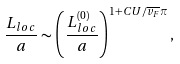Convert formula to latex. <formula><loc_0><loc_0><loc_500><loc_500>\frac { L _ { l o c } } { a } \sim \left ( \frac { L _ { l o c } ^ { ( 0 ) } } { a } \right ) ^ { 1 + C U / \overline { v _ { F } } \pi } ,</formula> 